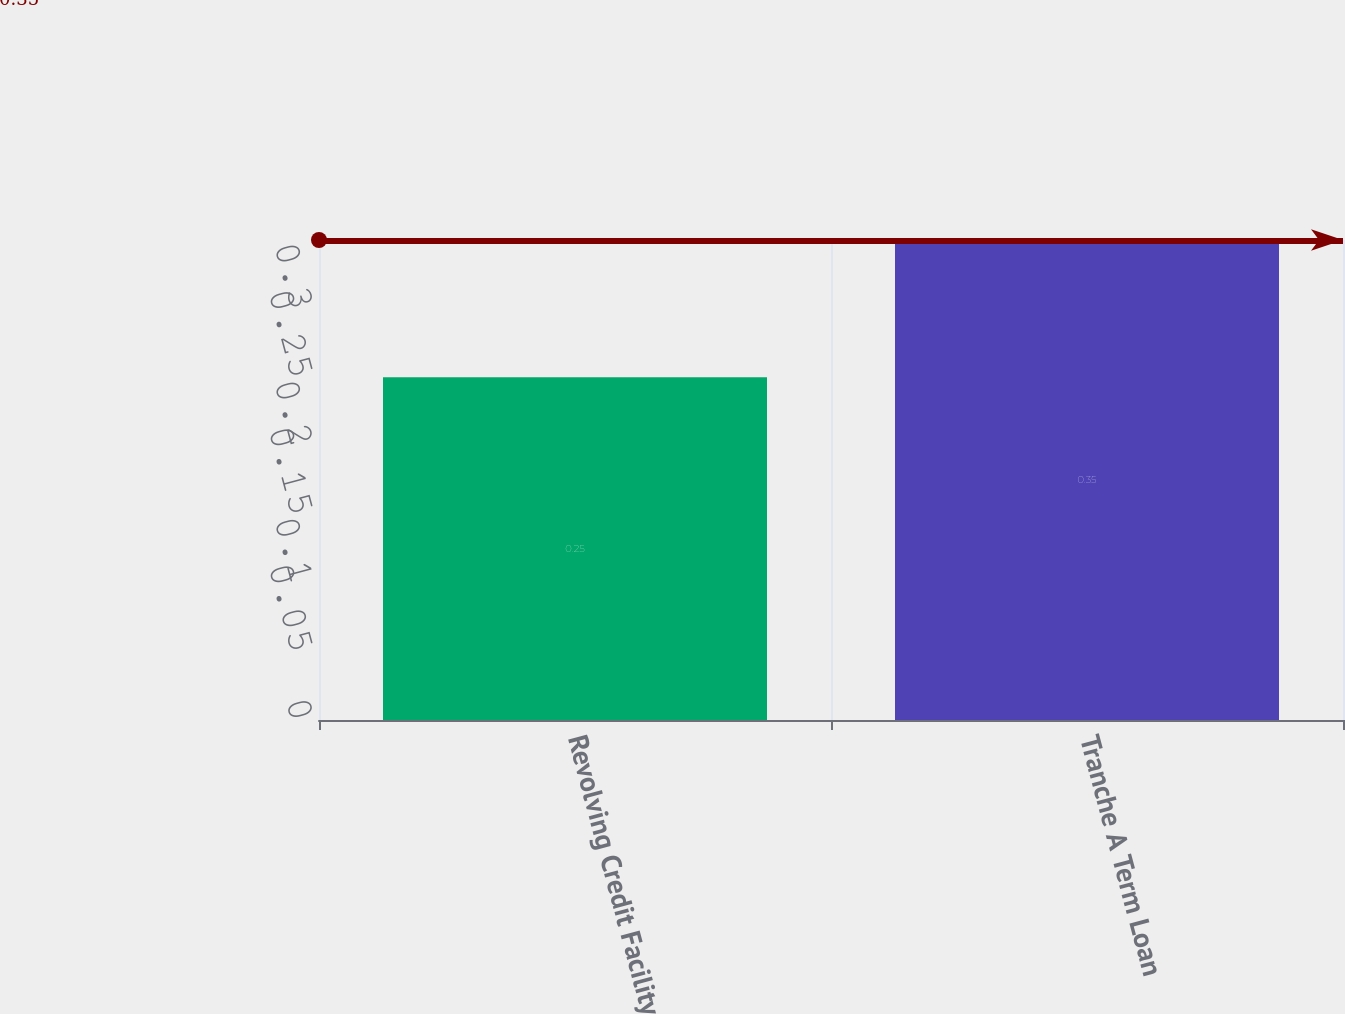<chart> <loc_0><loc_0><loc_500><loc_500><bar_chart><fcel>Revolving Credit Facility<fcel>Tranche A Term Loan<nl><fcel>0.25<fcel>0.35<nl></chart> 